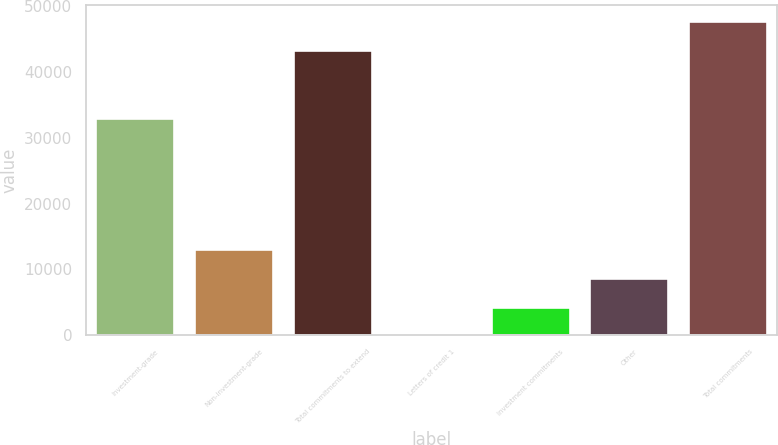<chart> <loc_0><loc_0><loc_500><loc_500><bar_chart><fcel>Investment-grade<fcel>Non-investment-grade<fcel>Total commitments to extend<fcel>Letters of credit 1<fcel>Investment commitments<fcel>Other<fcel>Total commitments<nl><fcel>32960<fcel>13039<fcel>43356<fcel>10<fcel>4353<fcel>8696<fcel>47699<nl></chart> 